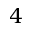Convert formula to latex. <formula><loc_0><loc_0><loc_500><loc_500>4</formula> 